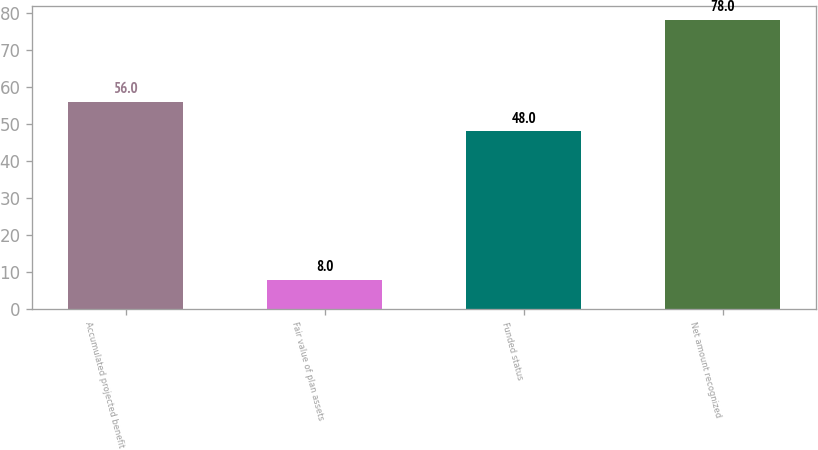Convert chart to OTSL. <chart><loc_0><loc_0><loc_500><loc_500><bar_chart><fcel>Accumulated projected benefit<fcel>Fair value of plan assets<fcel>Funded status<fcel>Net amount recognized<nl><fcel>56<fcel>8<fcel>48<fcel>78<nl></chart> 